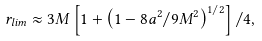Convert formula to latex. <formula><loc_0><loc_0><loc_500><loc_500>r _ { l i m } \approx 3 M \left [ 1 + \left ( 1 - 8 a ^ { 2 } / 9 M ^ { 2 } \right ) ^ { 1 / 2 } \right ] / 4 ,</formula> 